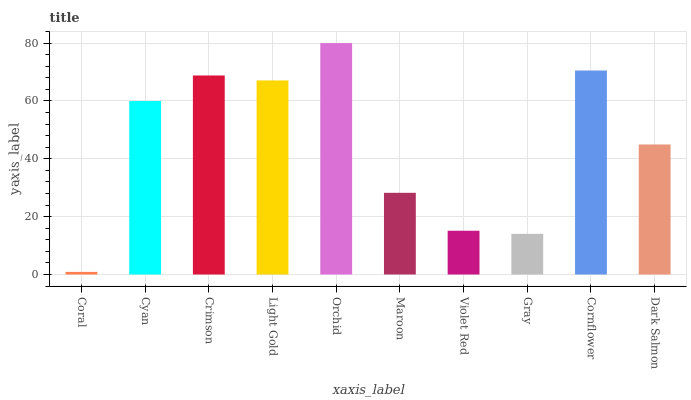Is Cyan the minimum?
Answer yes or no. No. Is Cyan the maximum?
Answer yes or no. No. Is Cyan greater than Coral?
Answer yes or no. Yes. Is Coral less than Cyan?
Answer yes or no. Yes. Is Coral greater than Cyan?
Answer yes or no. No. Is Cyan less than Coral?
Answer yes or no. No. Is Cyan the high median?
Answer yes or no. Yes. Is Dark Salmon the low median?
Answer yes or no. Yes. Is Violet Red the high median?
Answer yes or no. No. Is Light Gold the low median?
Answer yes or no. No. 